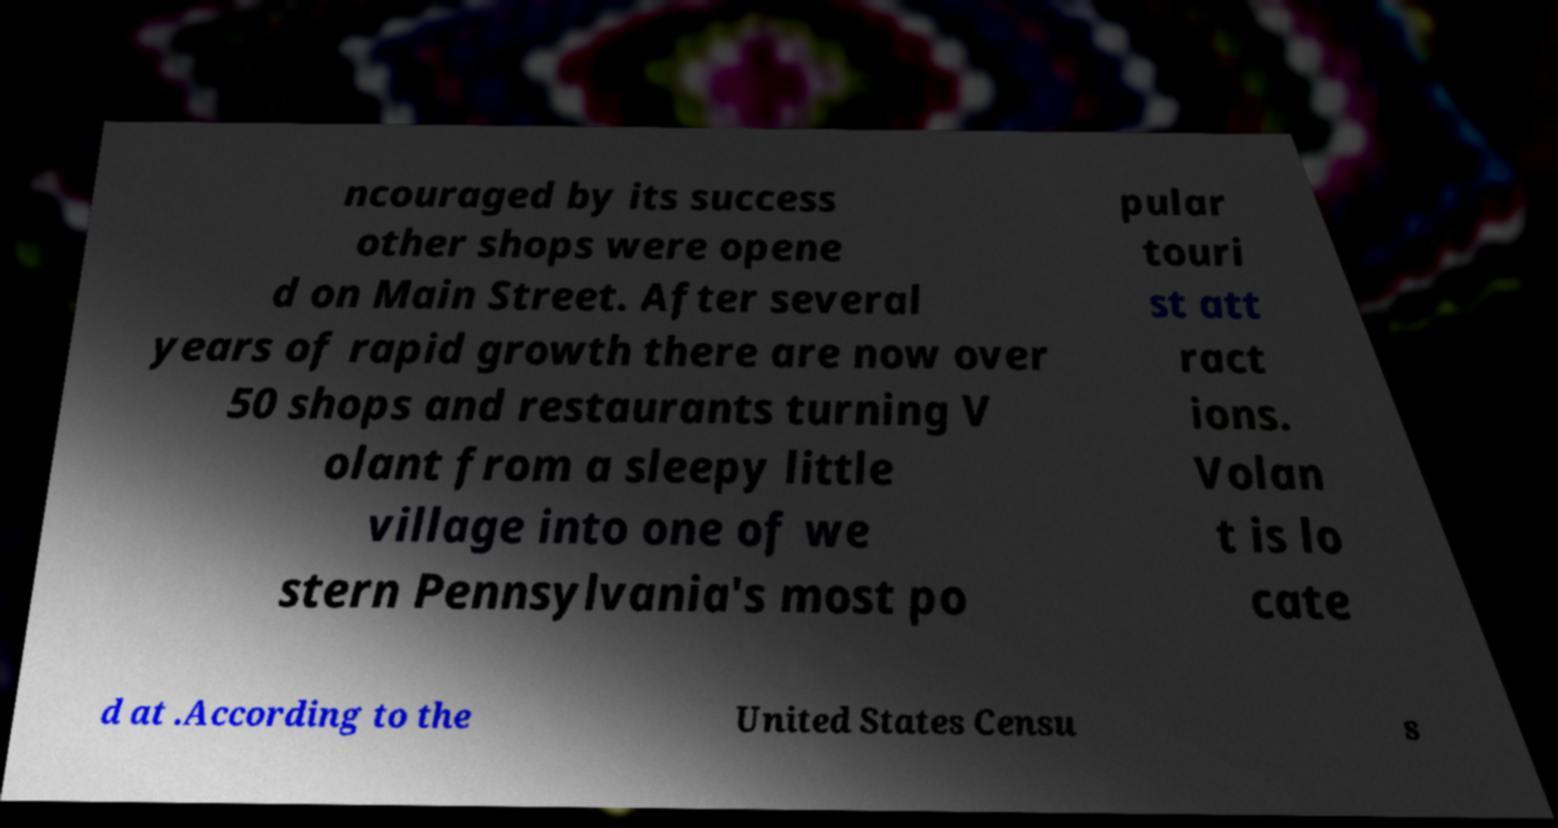Please read and relay the text visible in this image. What does it say? ncouraged by its success other shops were opene d on Main Street. After several years of rapid growth there are now over 50 shops and restaurants turning V olant from a sleepy little village into one of we stern Pennsylvania's most po pular touri st att ract ions. Volan t is lo cate d at .According to the United States Censu s 